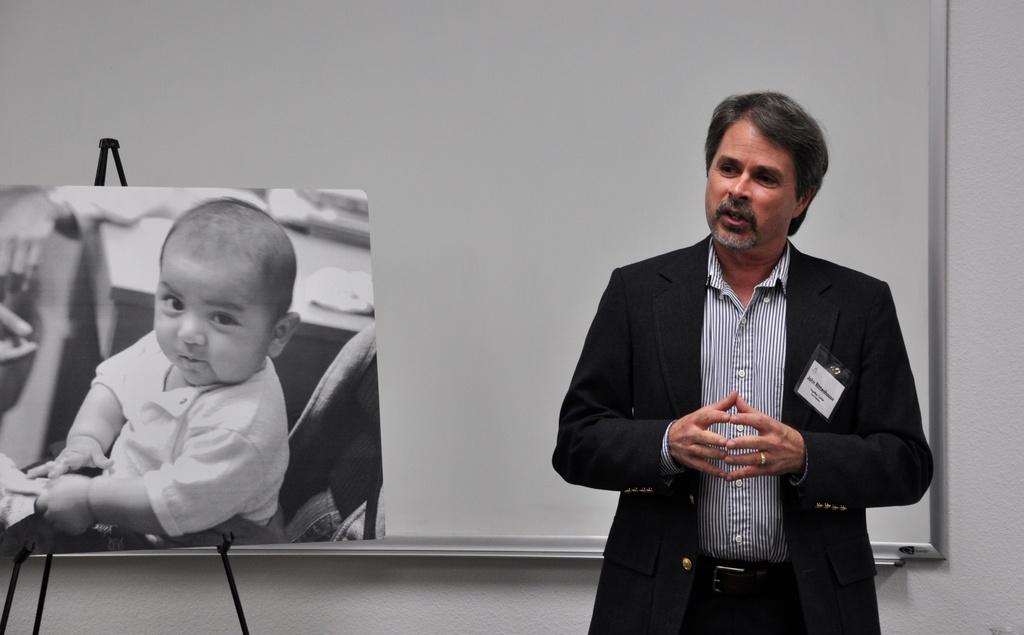What is the main subject of the image? There is a man standing in the image. What else can be seen in the image besides the man? There is a black and white picture of a child with a stand in the image. Can you describe the board on the wall in the image? There is a board on a wall in the image. What type of fact can be seen flying in the sky in the image? There is no fact visible in the image, let alone one flying in the sky. 